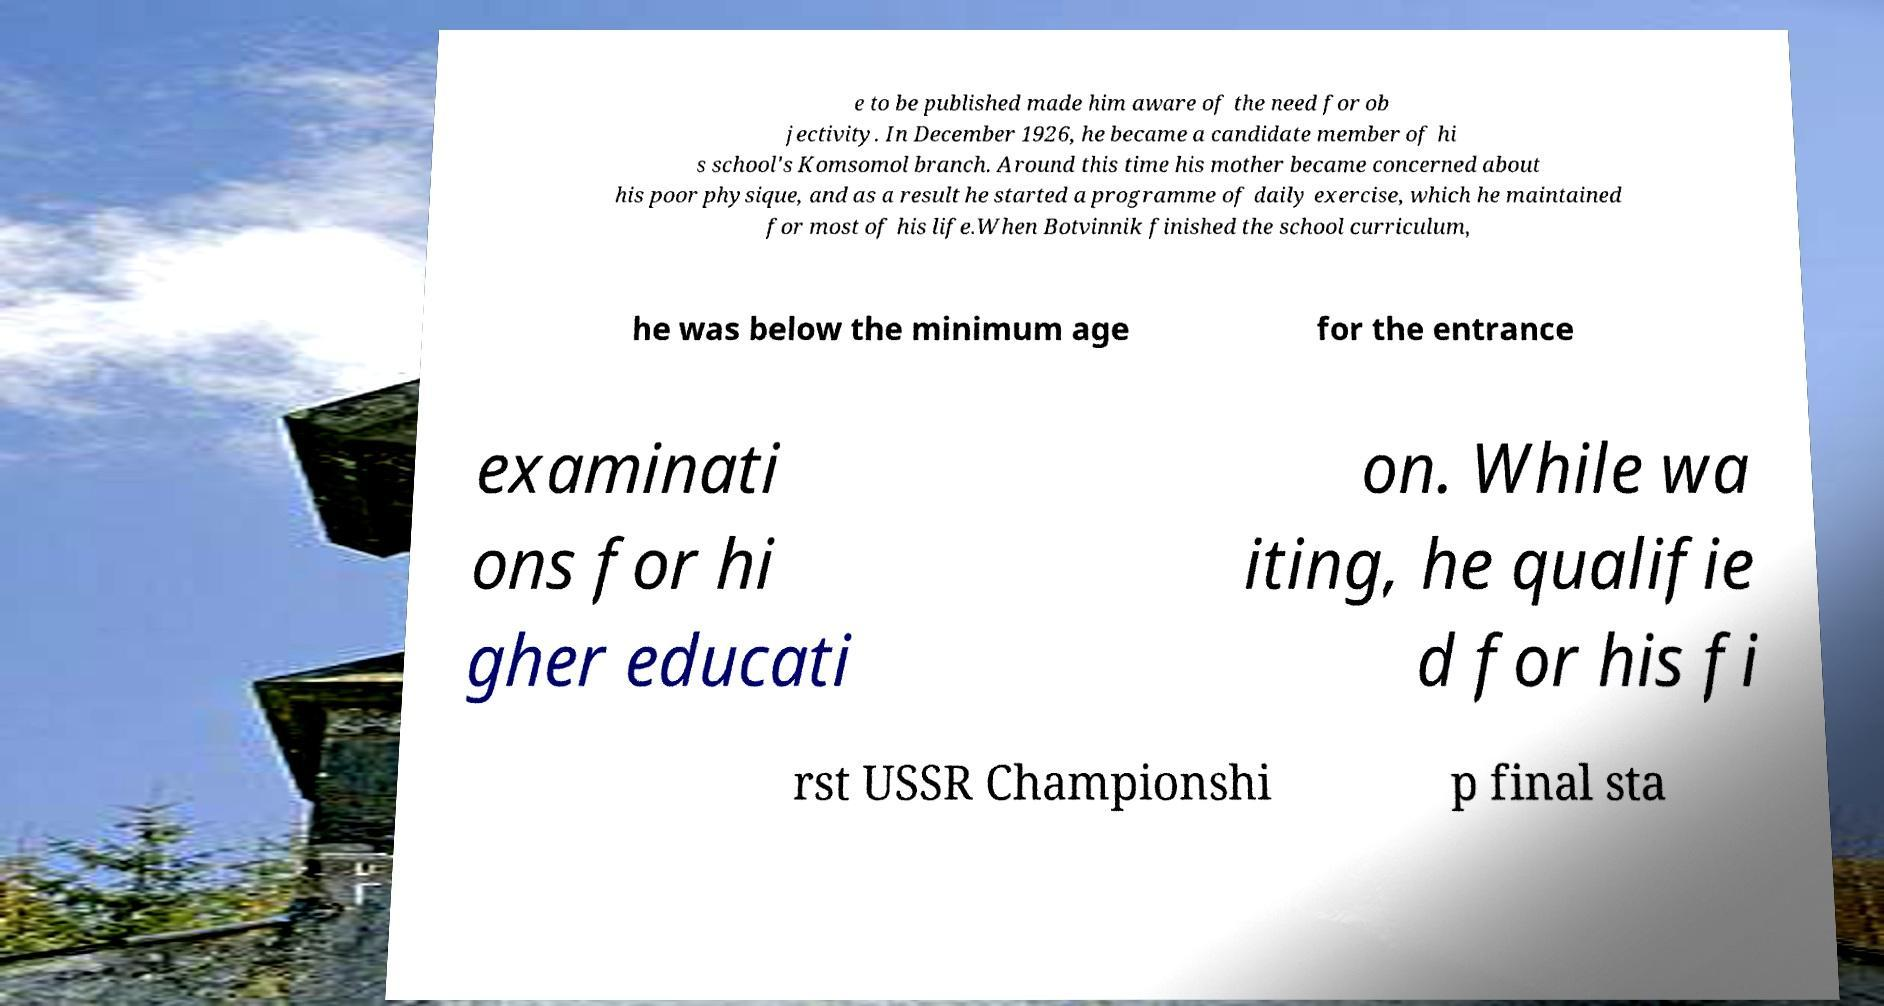Could you assist in decoding the text presented in this image and type it out clearly? e to be published made him aware of the need for ob jectivity. In December 1926, he became a candidate member of hi s school's Komsomol branch. Around this time his mother became concerned about his poor physique, and as a result he started a programme of daily exercise, which he maintained for most of his life.When Botvinnik finished the school curriculum, he was below the minimum age for the entrance examinati ons for hi gher educati on. While wa iting, he qualifie d for his fi rst USSR Championshi p final sta 